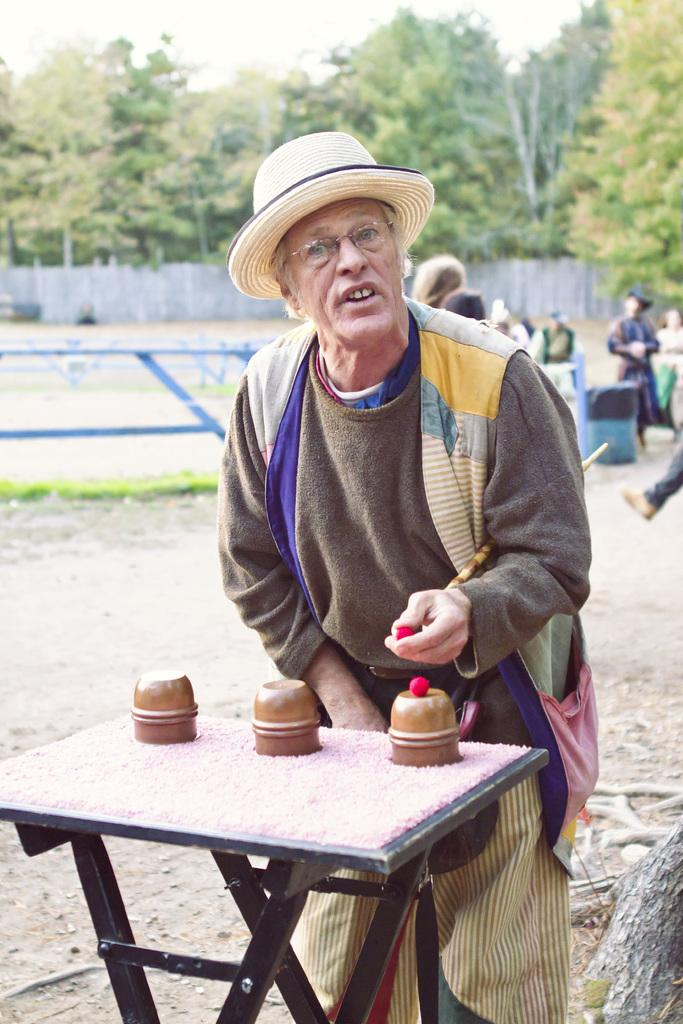Who is the main subject in the image? There is an old man in the image. What is the old man doing in the image? The old man is performing a magic trick. Can you describe the magic trick being performed? The magic trick involves red balls and cups. Where is the faucet located in the image? There is no faucet present in the image. What type of dock is visible in the image? There is no dock present in the image. 